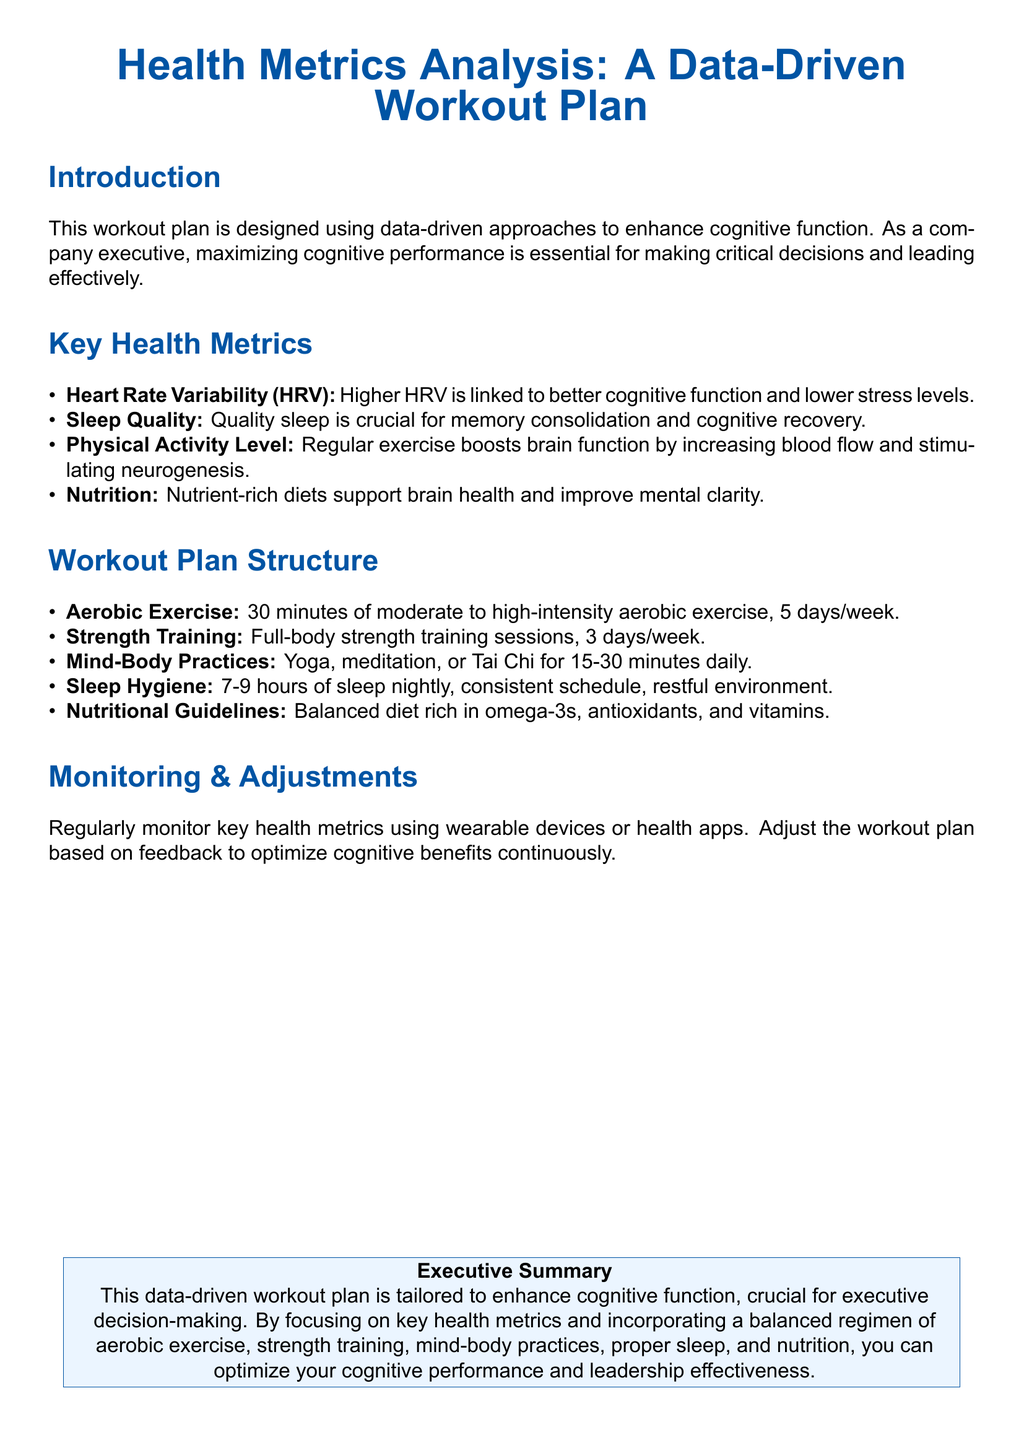What is the primary goal of the workout plan? The workout plan aims to enhance cognitive function.
Answer: enhance cognitive function How many days per week is aerobic exercise recommended? The document states that aerobic exercise should be performed 5 days per week.
Answer: 5 days/week What is the recommended duration for mind-body practices? The plan suggests practicing for 15-30 minutes daily.
Answer: 15-30 minutes What type of training is recommended 3 days a week? The workout plan includes full-body strength training sessions.
Answer: strength training What key health metric is linked to better cognitive function? Higher Heart Rate Variability (HRV) is associated with enhanced cognitive function.
Answer: HRV How many hours of sleep is suggested for optimal performance? The document recommends 7-9 hours of sleep nightly.
Answer: 7-9 hours What does the nutritional guideline emphasize for brain health? The nutritional guidelines focus on a balanced diet rich in omega-3s, antioxidants, and vitamins.
Answer: omega-3s, antioxidants, and vitamins Why is monitoring key health metrics important according to the document? Regular monitoring allows for adjustments in the workout plan to optimize cognitive benefits.
Answer: optimize cognitive benefits What type of exercise is encouraged alongside strength training? Aerobic exercise is encouraged in addition to strength training.
Answer: Aerobic exercise 